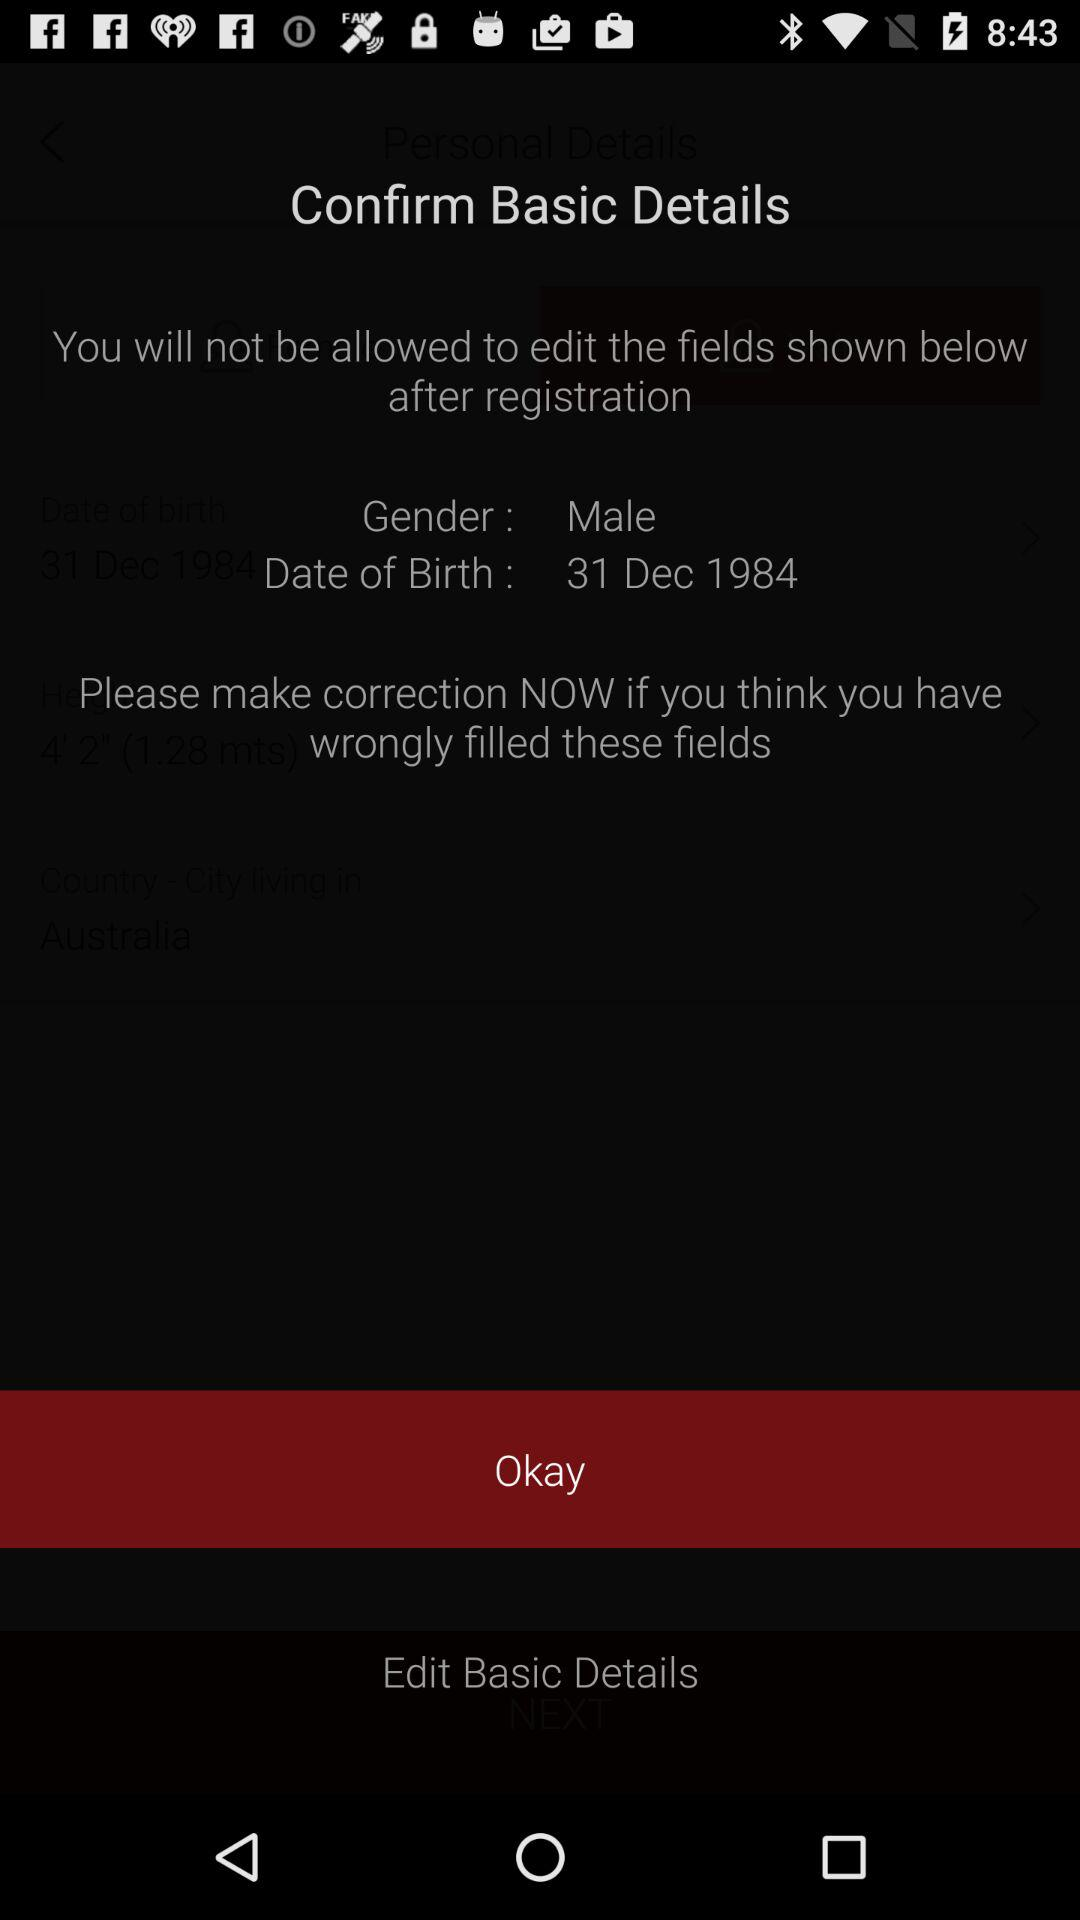What is the mentioned gender? The mentioned gender is male. 